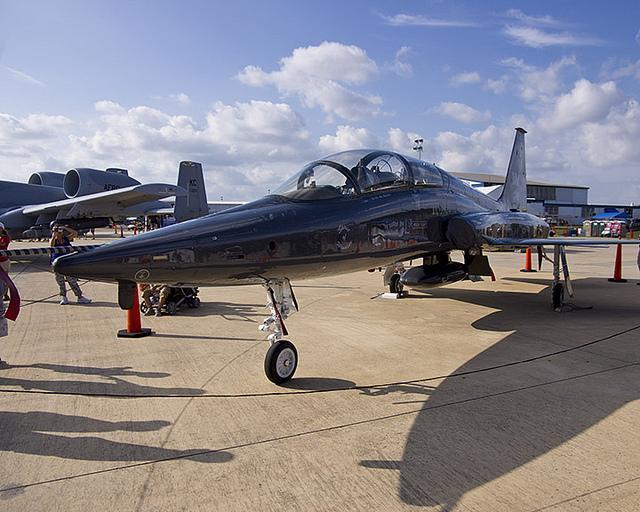Why is the plane parked here?
Choose the right answer from the provided options to respond to the question.
Options: Cleaning, on display, maintenance, for sale. On display. 